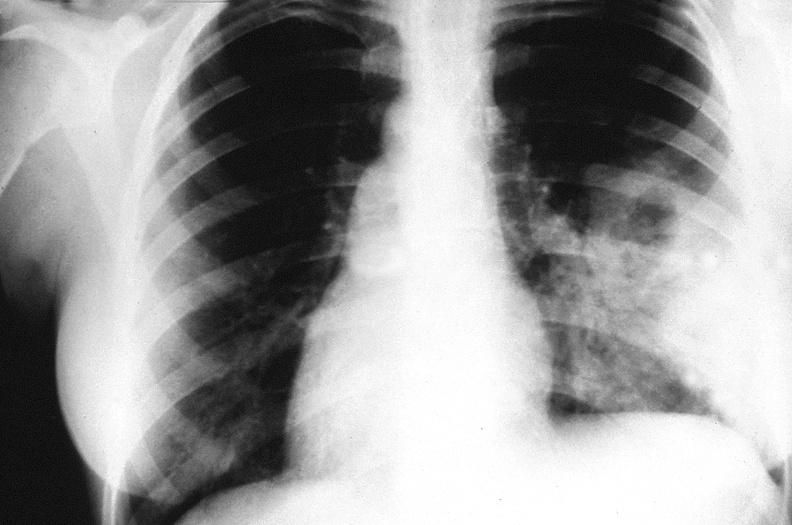what is present?
Answer the question using a single word or phrase. Respiratory 